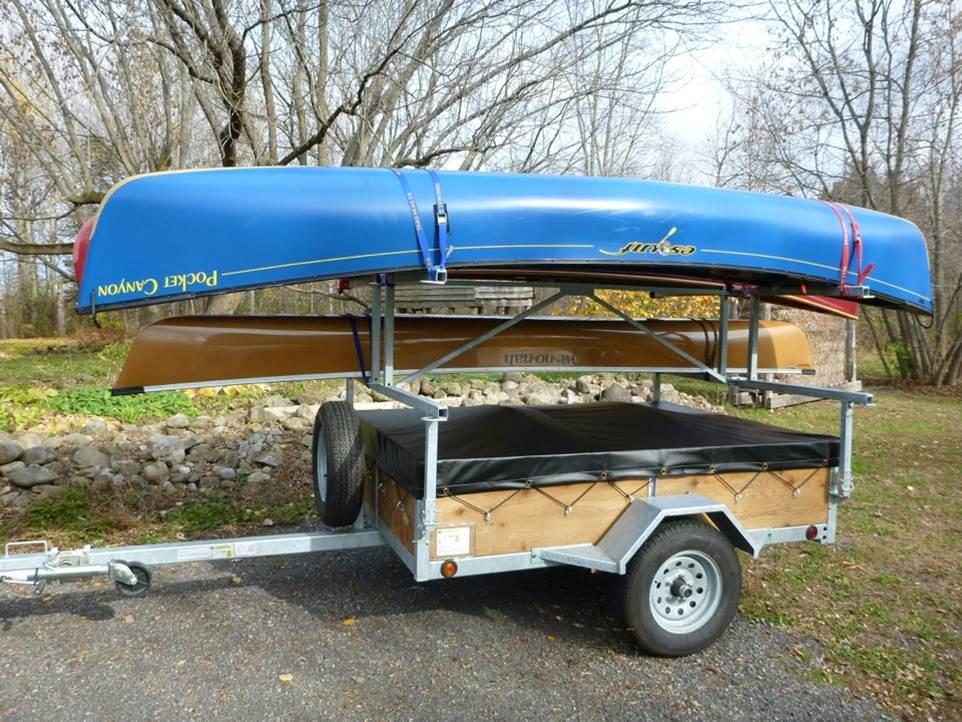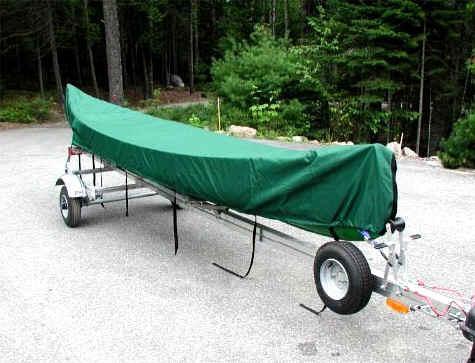The first image is the image on the left, the second image is the image on the right. For the images shown, is this caption "At least one canoe is loaded onto a wooden trailer with a black cover in the image on the left." true? Answer yes or no. Yes. The first image is the image on the left, the second image is the image on the right. For the images shown, is this caption "There is a green canoe above a red canoe in the right image." true? Answer yes or no. No. 